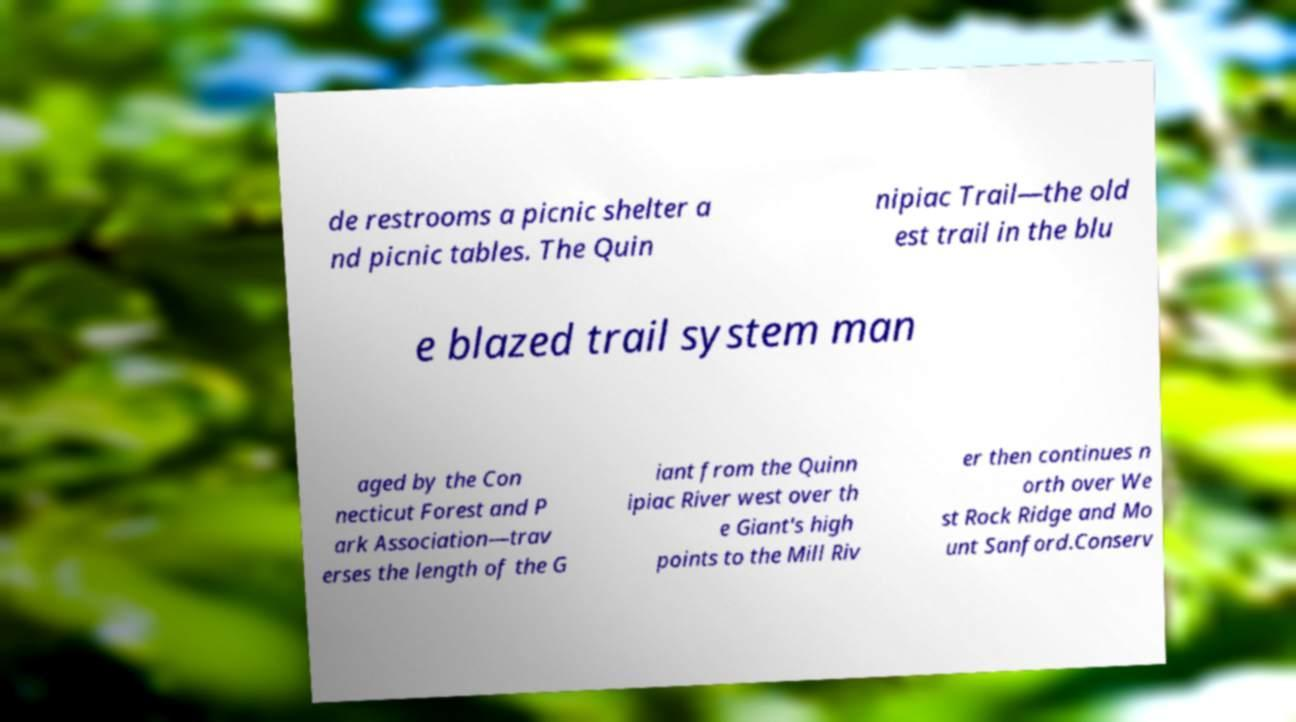Please identify and transcribe the text found in this image. de restrooms a picnic shelter a nd picnic tables. The Quin nipiac Trail—the old est trail in the blu e blazed trail system man aged by the Con necticut Forest and P ark Association—trav erses the length of the G iant from the Quinn ipiac River west over th e Giant's high points to the Mill Riv er then continues n orth over We st Rock Ridge and Mo unt Sanford.Conserv 